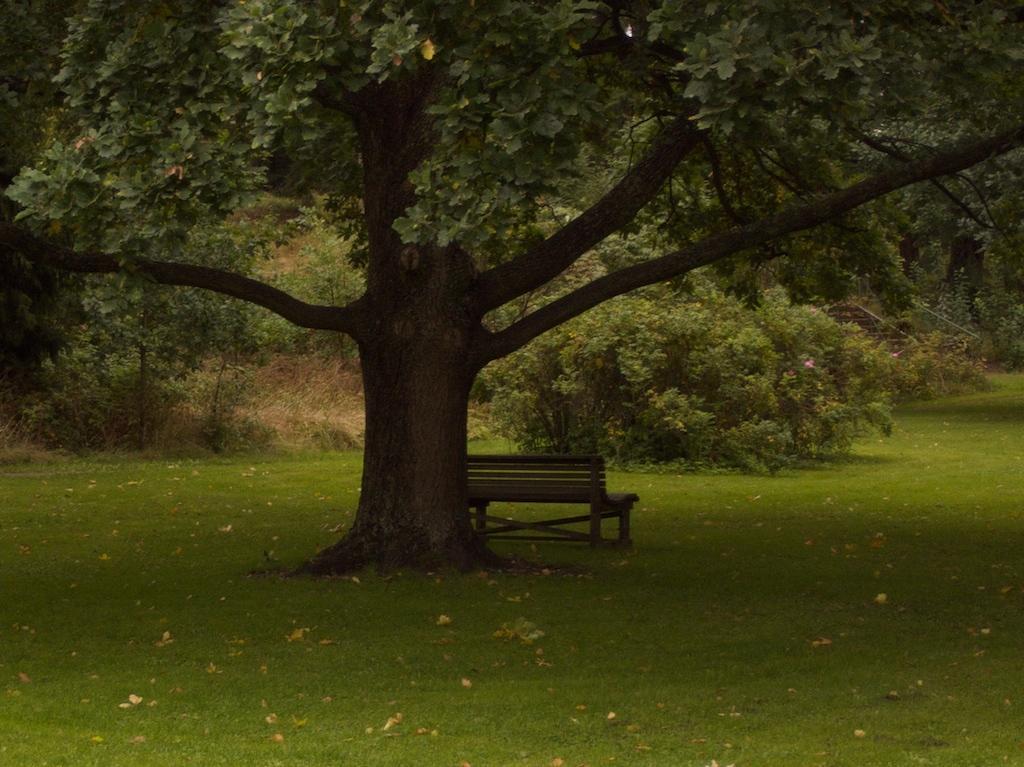In one or two sentences, can you explain what this image depicts? In this image I can see the grass. I can see a bench. In the background, I can see the trees. 